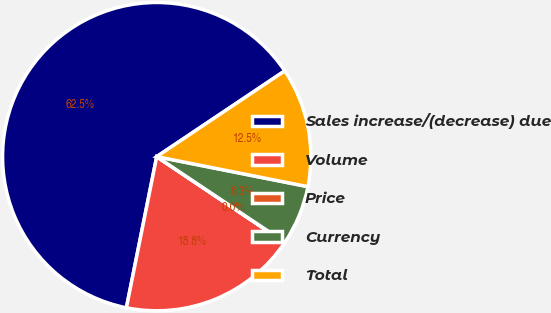Convert chart. <chart><loc_0><loc_0><loc_500><loc_500><pie_chart><fcel>Sales increase/(decrease) due<fcel>Volume<fcel>Price<fcel>Currency<fcel>Total<nl><fcel>62.45%<fcel>18.75%<fcel>0.02%<fcel>6.26%<fcel>12.51%<nl></chart> 